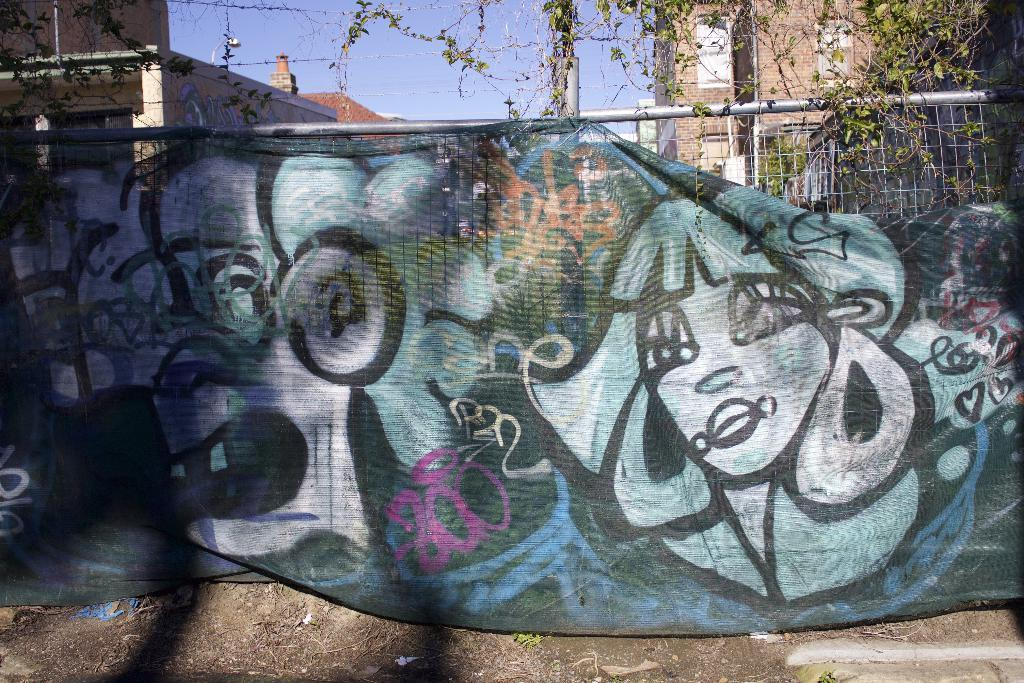What is hanging on the fence in the image? There is a banner on a fence in the image. What type of vegetation can be seen in the image? There are leaves visible in the image. What can be seen in the distance in the image? There are buildings in the background of the image. What is visible above the buildings in the image? The sky is visible in the background of the image. What type of rice is being cooked in the image? There is no rice present in the image; it features a banner on a fence, leaves, buildings, and the sky. 